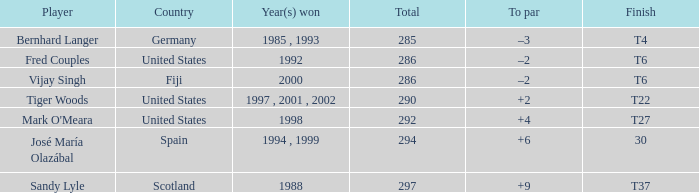Which player has a cumulative score above 290 and +4 to par? Mark O'Meara. Would you mind parsing the complete table? {'header': ['Player', 'Country', 'Year(s) won', 'Total', 'To par', 'Finish'], 'rows': [['Bernhard Langer', 'Germany', '1985 , 1993', '285', '–3', 'T4'], ['Fred Couples', 'United States', '1992', '286', '–2', 'T6'], ['Vijay Singh', 'Fiji', '2000', '286', '–2', 'T6'], ['Tiger Woods', 'United States', '1997 , 2001 , 2002', '290', '+2', 'T22'], ["Mark O'Meara", 'United States', '1998', '292', '+4', 'T27'], ['José María Olazábal', 'Spain', '1994 , 1999', '294', '+6', '30'], ['Sandy Lyle', 'Scotland', '1988', '297', '+9', 'T37']]} 